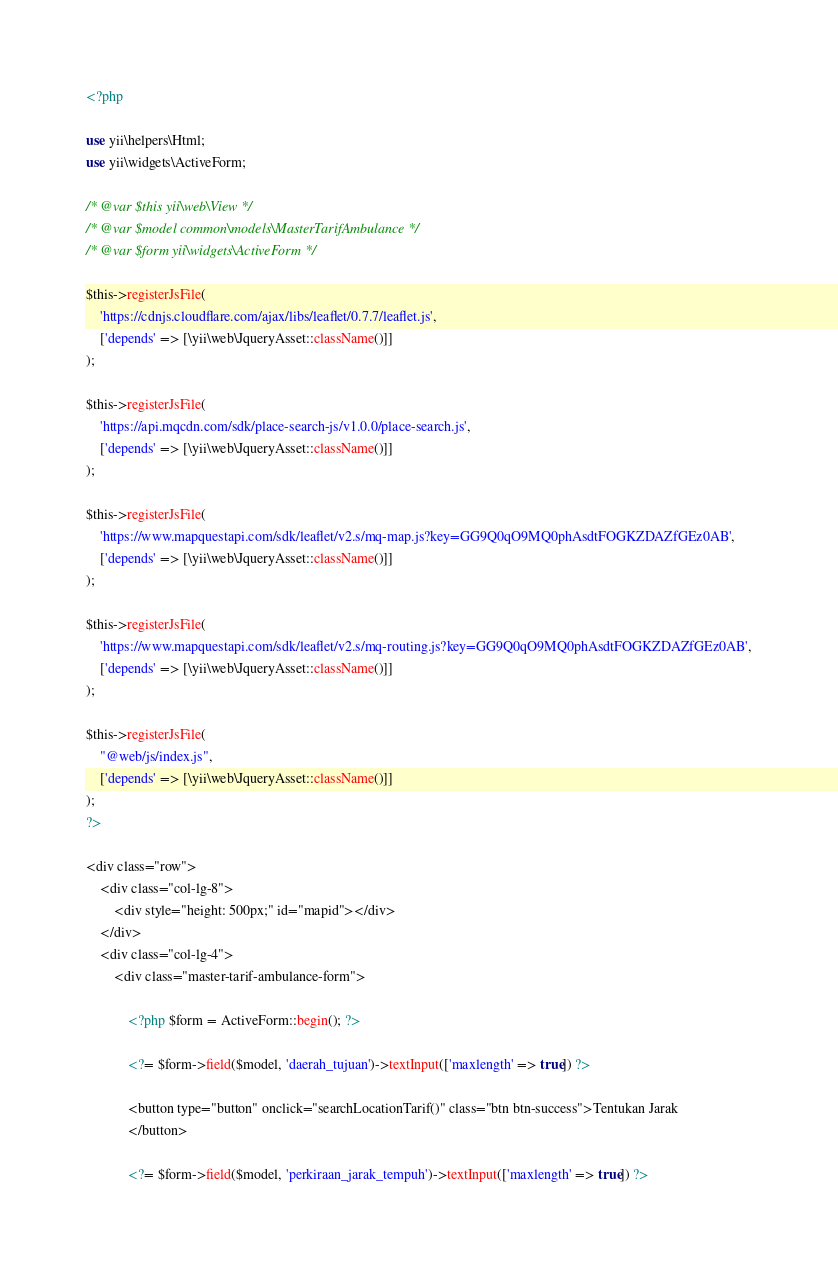Convert code to text. <code><loc_0><loc_0><loc_500><loc_500><_PHP_><?php

use yii\helpers\Html;
use yii\widgets\ActiveForm;

/* @var $this yii\web\View */
/* @var $model common\models\MasterTarifAmbulance */
/* @var $form yii\widgets\ActiveForm */

$this->registerJsFile(
    'https://cdnjs.cloudflare.com/ajax/libs/leaflet/0.7.7/leaflet.js',
    ['depends' => [\yii\web\JqueryAsset::className()]]
);

$this->registerJsFile(
    'https://api.mqcdn.com/sdk/place-search-js/v1.0.0/place-search.js',
    ['depends' => [\yii\web\JqueryAsset::className()]]
);

$this->registerJsFile(
    'https://www.mapquestapi.com/sdk/leaflet/v2.s/mq-map.js?key=GG9Q0qO9MQ0phAsdtFOGKZDAZfGEz0AB',
    ['depends' => [\yii\web\JqueryAsset::className()]]
);

$this->registerJsFile(
    'https://www.mapquestapi.com/sdk/leaflet/v2.s/mq-routing.js?key=GG9Q0qO9MQ0phAsdtFOGKZDAZfGEz0AB',
    ['depends' => [\yii\web\JqueryAsset::className()]]
);

$this->registerJsFile(
    "@web/js/index.js",
    ['depends' => [\yii\web\JqueryAsset::className()]]
);
?>

<div class="row">
    <div class="col-lg-8">
        <div style="height: 500px;" id="mapid"></div>
    </div>
    <div class="col-lg-4">
        <div class="master-tarif-ambulance-form">

            <?php $form = ActiveForm::begin(); ?>

            <?= $form->field($model, 'daerah_tujuan')->textInput(['maxlength' => true]) ?>

            <button type="button" onclick="searchLocationTarif()" class="btn btn-success">Tentukan Jarak
            </button>

            <?= $form->field($model, 'perkiraan_jarak_tempuh')->textInput(['maxlength' => true]) ?>
</code> 